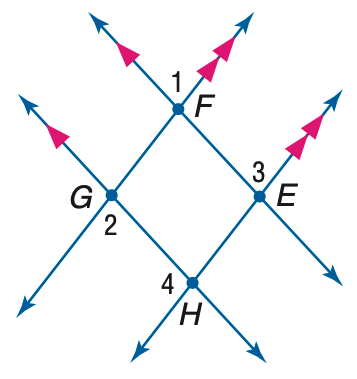Answer the mathemtical geometry problem and directly provide the correct option letter.
Question: If m \angle 1 = 3 x + 40, m \angle 2 = 2(y - 10), and m \angle 3 = 2 x + 70, find y.
Choices: A: 55 B: 60 C: 65 D: 75 D 